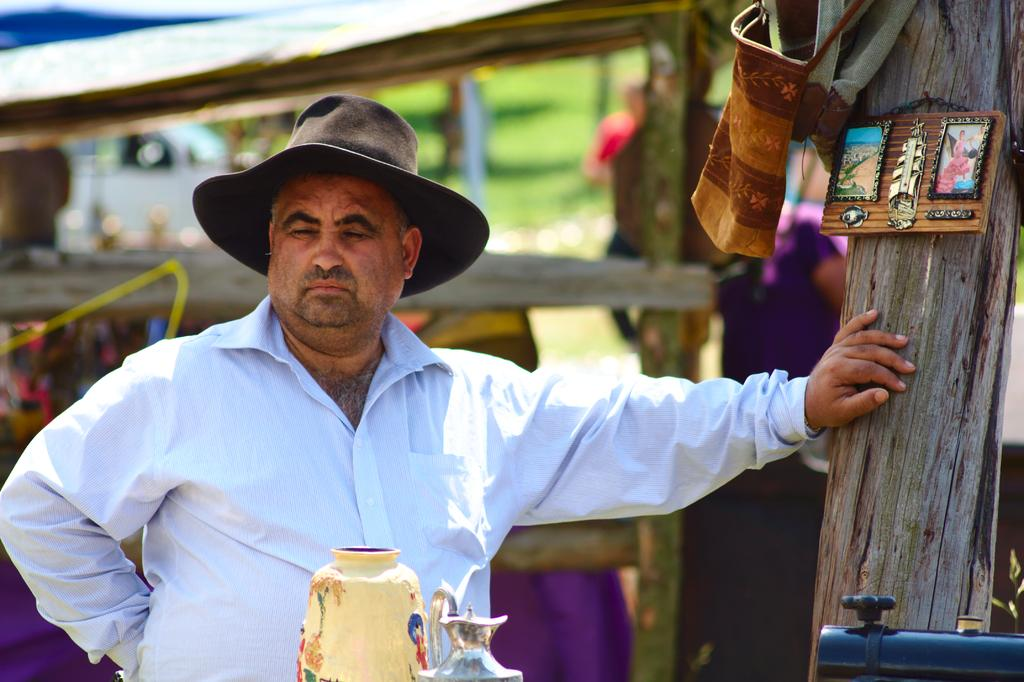What is the main subject of the image? There is a man standing in the center of the image. What is the man wearing on his head? The man is wearing a hat. What can be seen on the right side of the image? There is a frame on the right side of the image. What items are visible in the image? There are bags visible in the image. What is in the background of the image? There is a tent in the background of the image. Can you tell me how many goldfish are swimming in the image? There are no goldfish present in the image. What type of secretary is sitting next to the man in the image? There is no secretary present in the image; it only features a man standing in the center. 